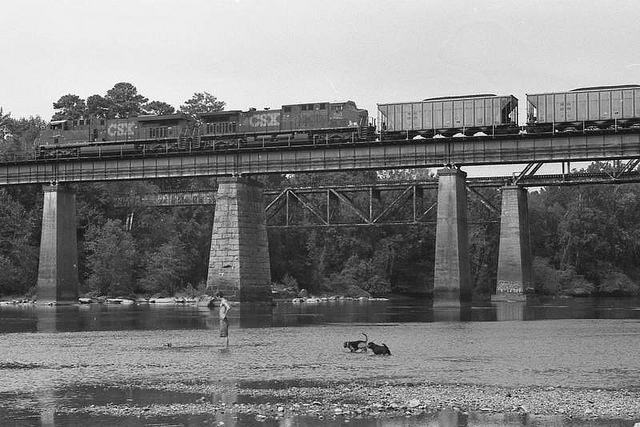What type of train is visible in the image, and what might it be carrying? The train in the image appears to be a freight locomotive, possibly carrying various goods. Given the type of the cars attached, it could be transporting commodities such as coal, minerals, or other raw materials. 